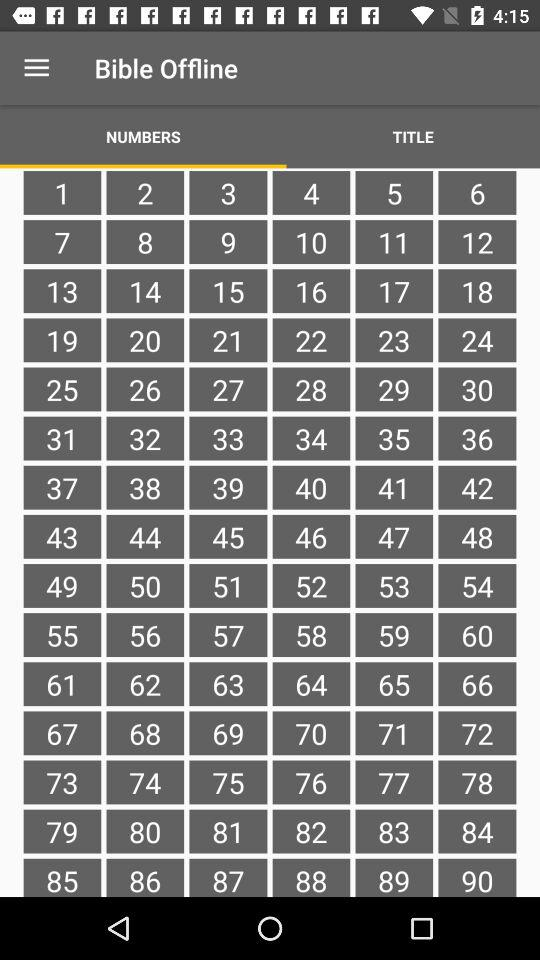Which tab is currently selected? The selected tab is "NUMBERS". 